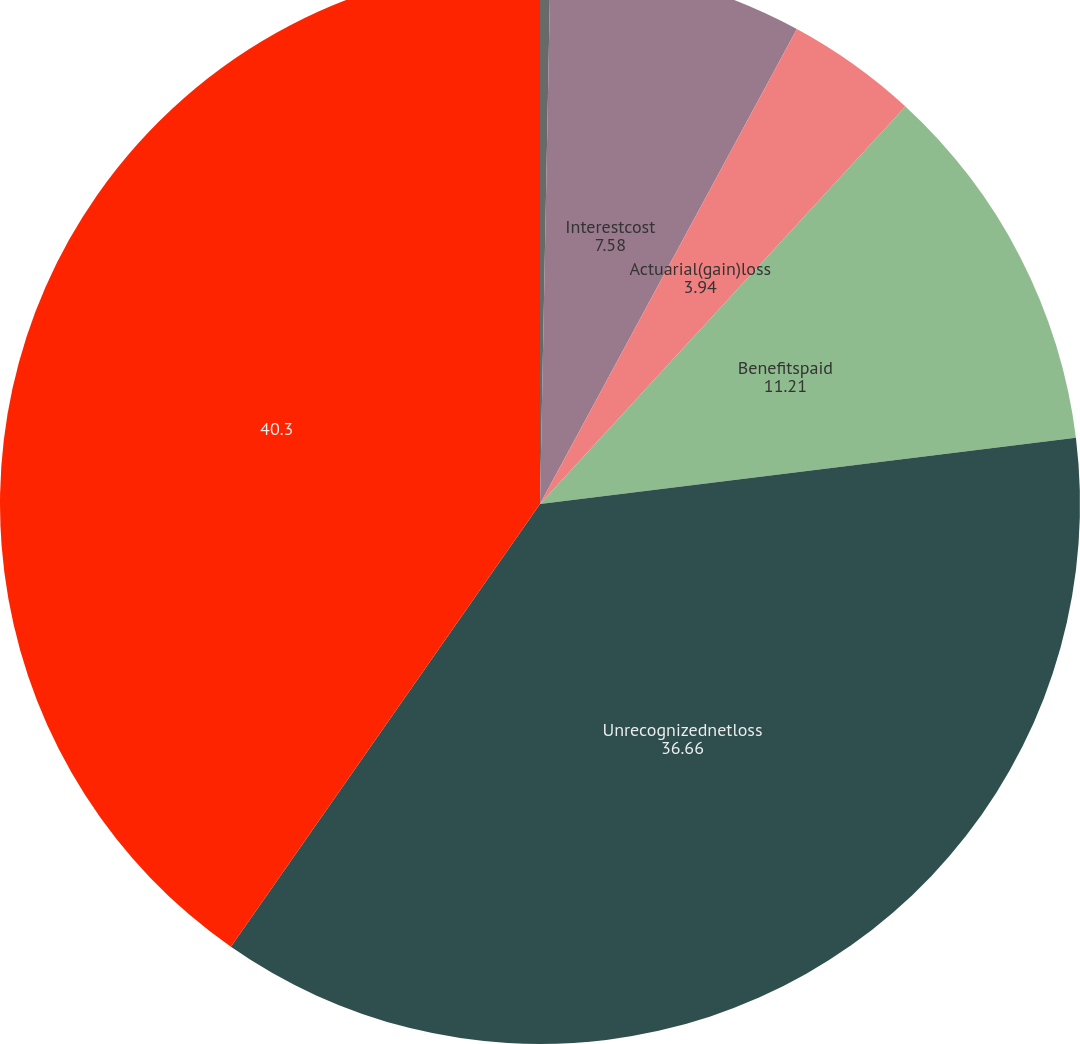Convert chart. <chart><loc_0><loc_0><loc_500><loc_500><pie_chart><fcel>Servicecost<fcel>Interestcost<fcel>Actuarial(gain)loss<fcel>Benefitspaid<fcel>Unrecognizednetloss<fcel>Unnamed: 5<nl><fcel>0.31%<fcel>7.58%<fcel>3.94%<fcel>11.21%<fcel>36.66%<fcel>40.3%<nl></chart> 